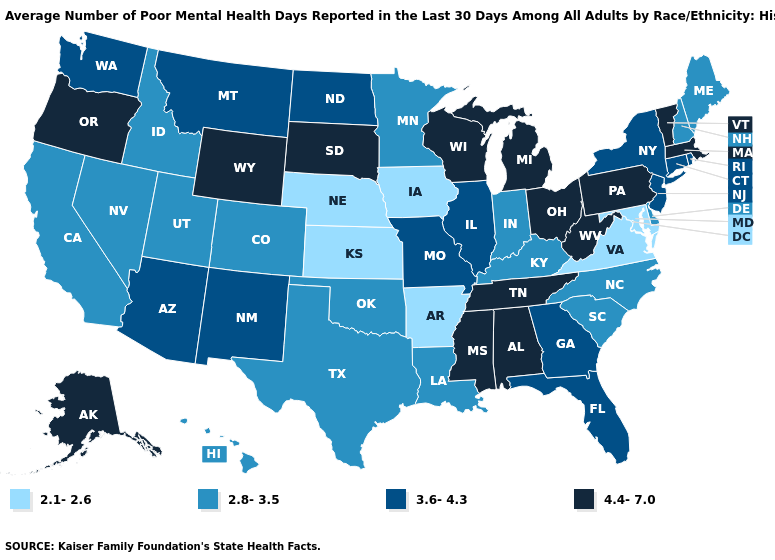Does the map have missing data?
Concise answer only. No. Name the states that have a value in the range 4.4-7.0?
Keep it brief. Alabama, Alaska, Massachusetts, Michigan, Mississippi, Ohio, Oregon, Pennsylvania, South Dakota, Tennessee, Vermont, West Virginia, Wisconsin, Wyoming. Among the states that border North Dakota , which have the lowest value?
Give a very brief answer. Minnesota. What is the highest value in the USA?
Be succinct. 4.4-7.0. Name the states that have a value in the range 4.4-7.0?
Quick response, please. Alabama, Alaska, Massachusetts, Michigan, Mississippi, Ohio, Oregon, Pennsylvania, South Dakota, Tennessee, Vermont, West Virginia, Wisconsin, Wyoming. Does Nebraska have the lowest value in the USA?
Short answer required. Yes. Name the states that have a value in the range 2.1-2.6?
Quick response, please. Arkansas, Iowa, Kansas, Maryland, Nebraska, Virginia. Is the legend a continuous bar?
Give a very brief answer. No. Is the legend a continuous bar?
Concise answer only. No. Which states hav the highest value in the West?
Short answer required. Alaska, Oregon, Wyoming. What is the highest value in the USA?
Keep it brief. 4.4-7.0. What is the value of Mississippi?
Quick response, please. 4.4-7.0. Name the states that have a value in the range 4.4-7.0?
Write a very short answer. Alabama, Alaska, Massachusetts, Michigan, Mississippi, Ohio, Oregon, Pennsylvania, South Dakota, Tennessee, Vermont, West Virginia, Wisconsin, Wyoming. Name the states that have a value in the range 4.4-7.0?
Write a very short answer. Alabama, Alaska, Massachusetts, Michigan, Mississippi, Ohio, Oregon, Pennsylvania, South Dakota, Tennessee, Vermont, West Virginia, Wisconsin, Wyoming. What is the value of South Dakota?
Write a very short answer. 4.4-7.0. 